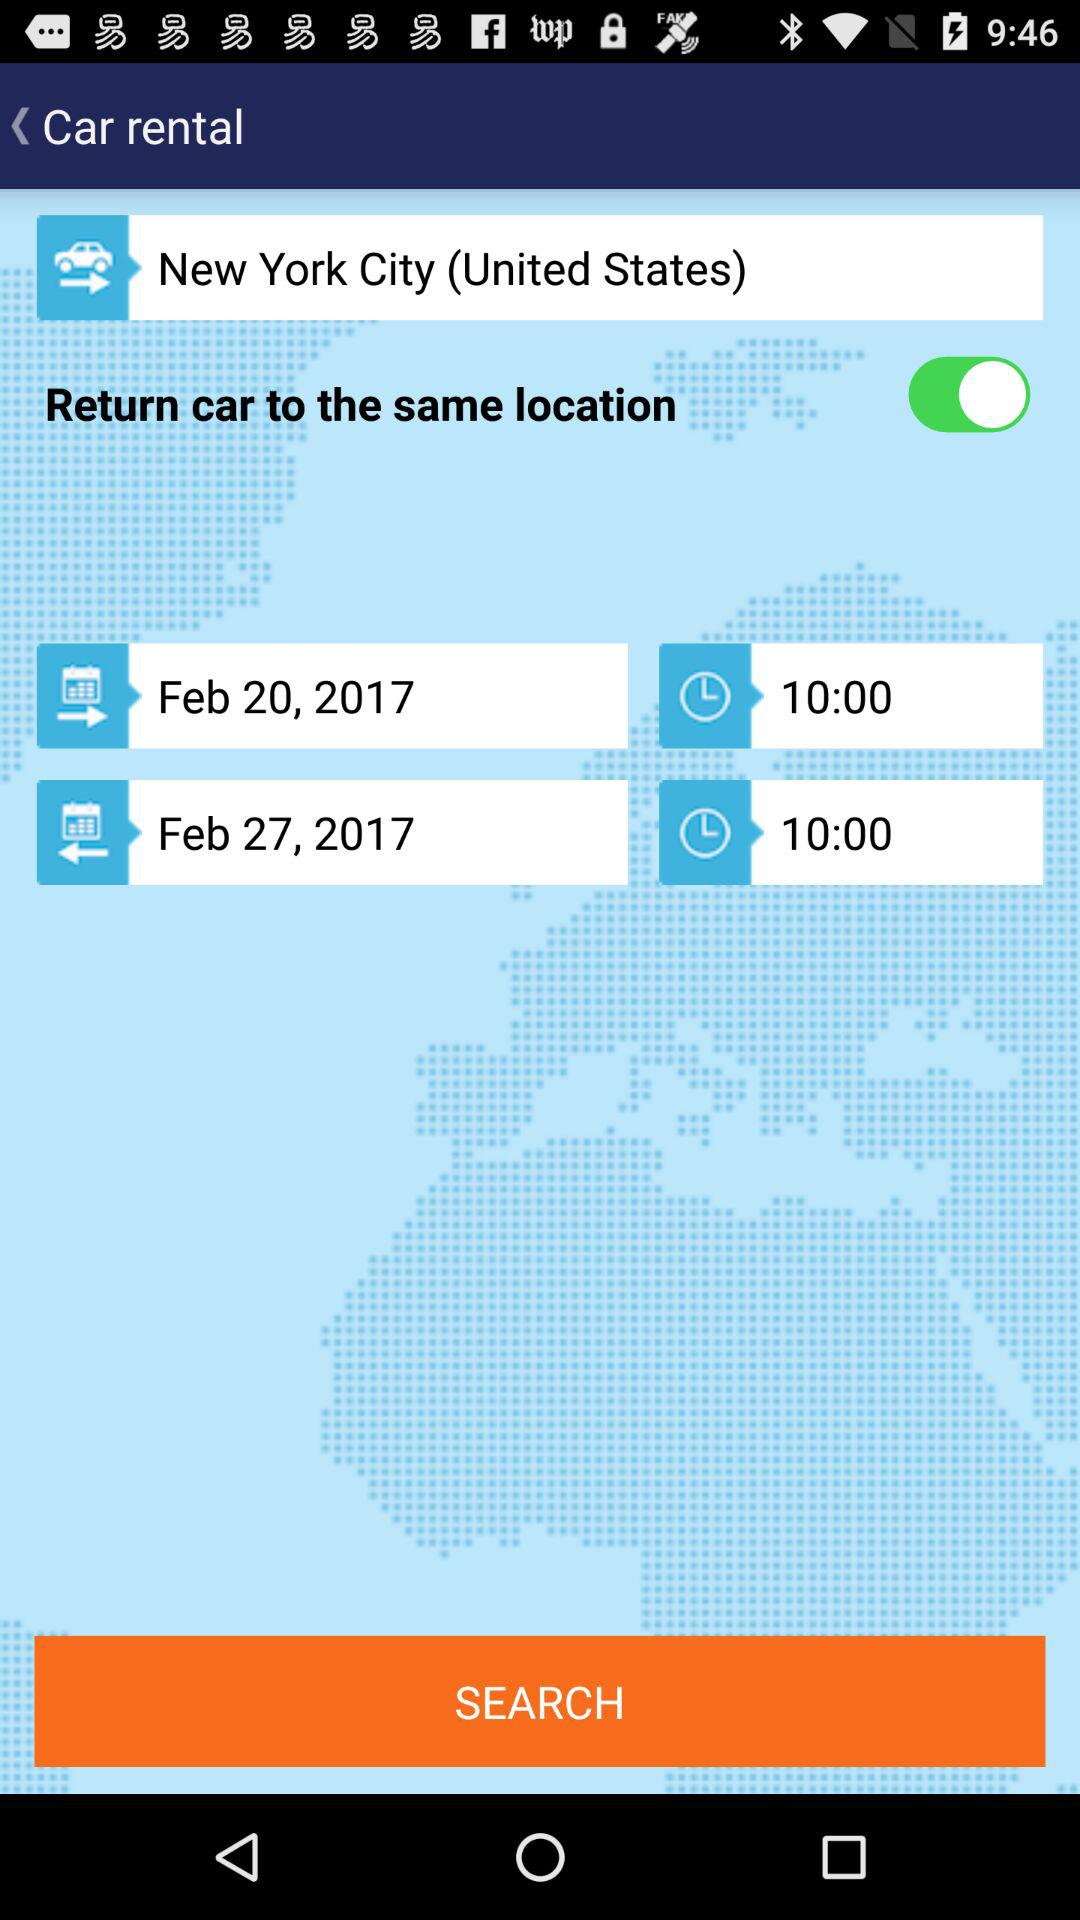What is the departure date? The departure date is February 20, 2017. 